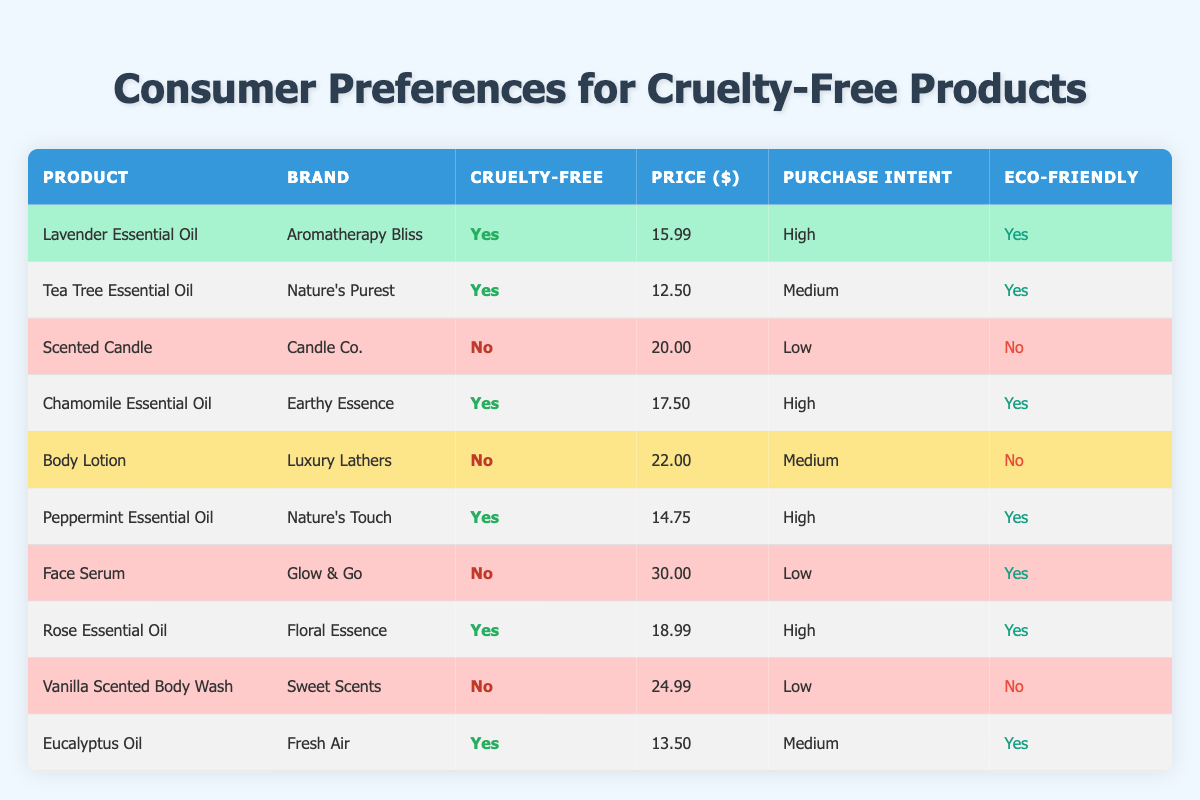What is the price of Lavender Essential Oil? The table lists Lavender Essential Oil under the product column with a corresponding price of 15.99 in the price column.
Answer: 15.99 How many products are cruelty-free? I can count the entries in the cruelty-free column that indicate "Yes." There are 6 products identified as cruelty-free.
Answer: 6 Is the Chamomile Essential Oil environmentally friendly? The table indicates that Chamomile Essential Oil has "Yes" in the environmentally friendly column.
Answer: Yes What is the average price of cruelty-free products? I will sum the prices of all cruelty-free products: (15.99 + 12.50 + 17.50 + 14.75 + 18.99 + 13.50) = 93.23. There are 6 cruelty-free products, so the average price is 93.23 / 6 = 15.54.
Answer: 15.54 Which product has the lowest purchase intent? By examining the purchase intent column, I note that there are three products with "Low" intent: Scented Candle, Face Serum, and Vanilla Scented Body Wash. All have the same purchase intent level, but to identify one, I can use other columns to differentiate. The first one listed is Scented Candle.
Answer: Scented Candle Are all scented candles cruelty-free? In the table, there is only one product labeled as Scented Candle, and its cruelty-free status is marked as "No." Therefore, it is not cruelty-free.
Answer: No What percentage of products are both cruelty-free and environmentally friendly? Out of the 10 products, 6 are cruelty-free and eco-friendly. To find the percentage, I calculate (6/10) * 100 = 60%.
Answer: 60% How many products have a purchase intent of 'high' and are also cruelty-free? I need to check the purchase intent column for "high" and the cruelty-free status. The products that satisfy both criteria are Lavender Essential Oil, Chamomile Essential Oil, Peppermint Essential Oil, and Rose Essential Oil. Therefore, there are 4 products.
Answer: 4 What is the price difference between the highest-priced and the lowest-priced cruelty-free products? The highest-priced cruelty-free product is Face Serum at 30.00, while the lowest is Tea Tree Essential Oil at 12.50. Therefore, the difference is 30.00 - 12.50 = 17.50.
Answer: 17.50 